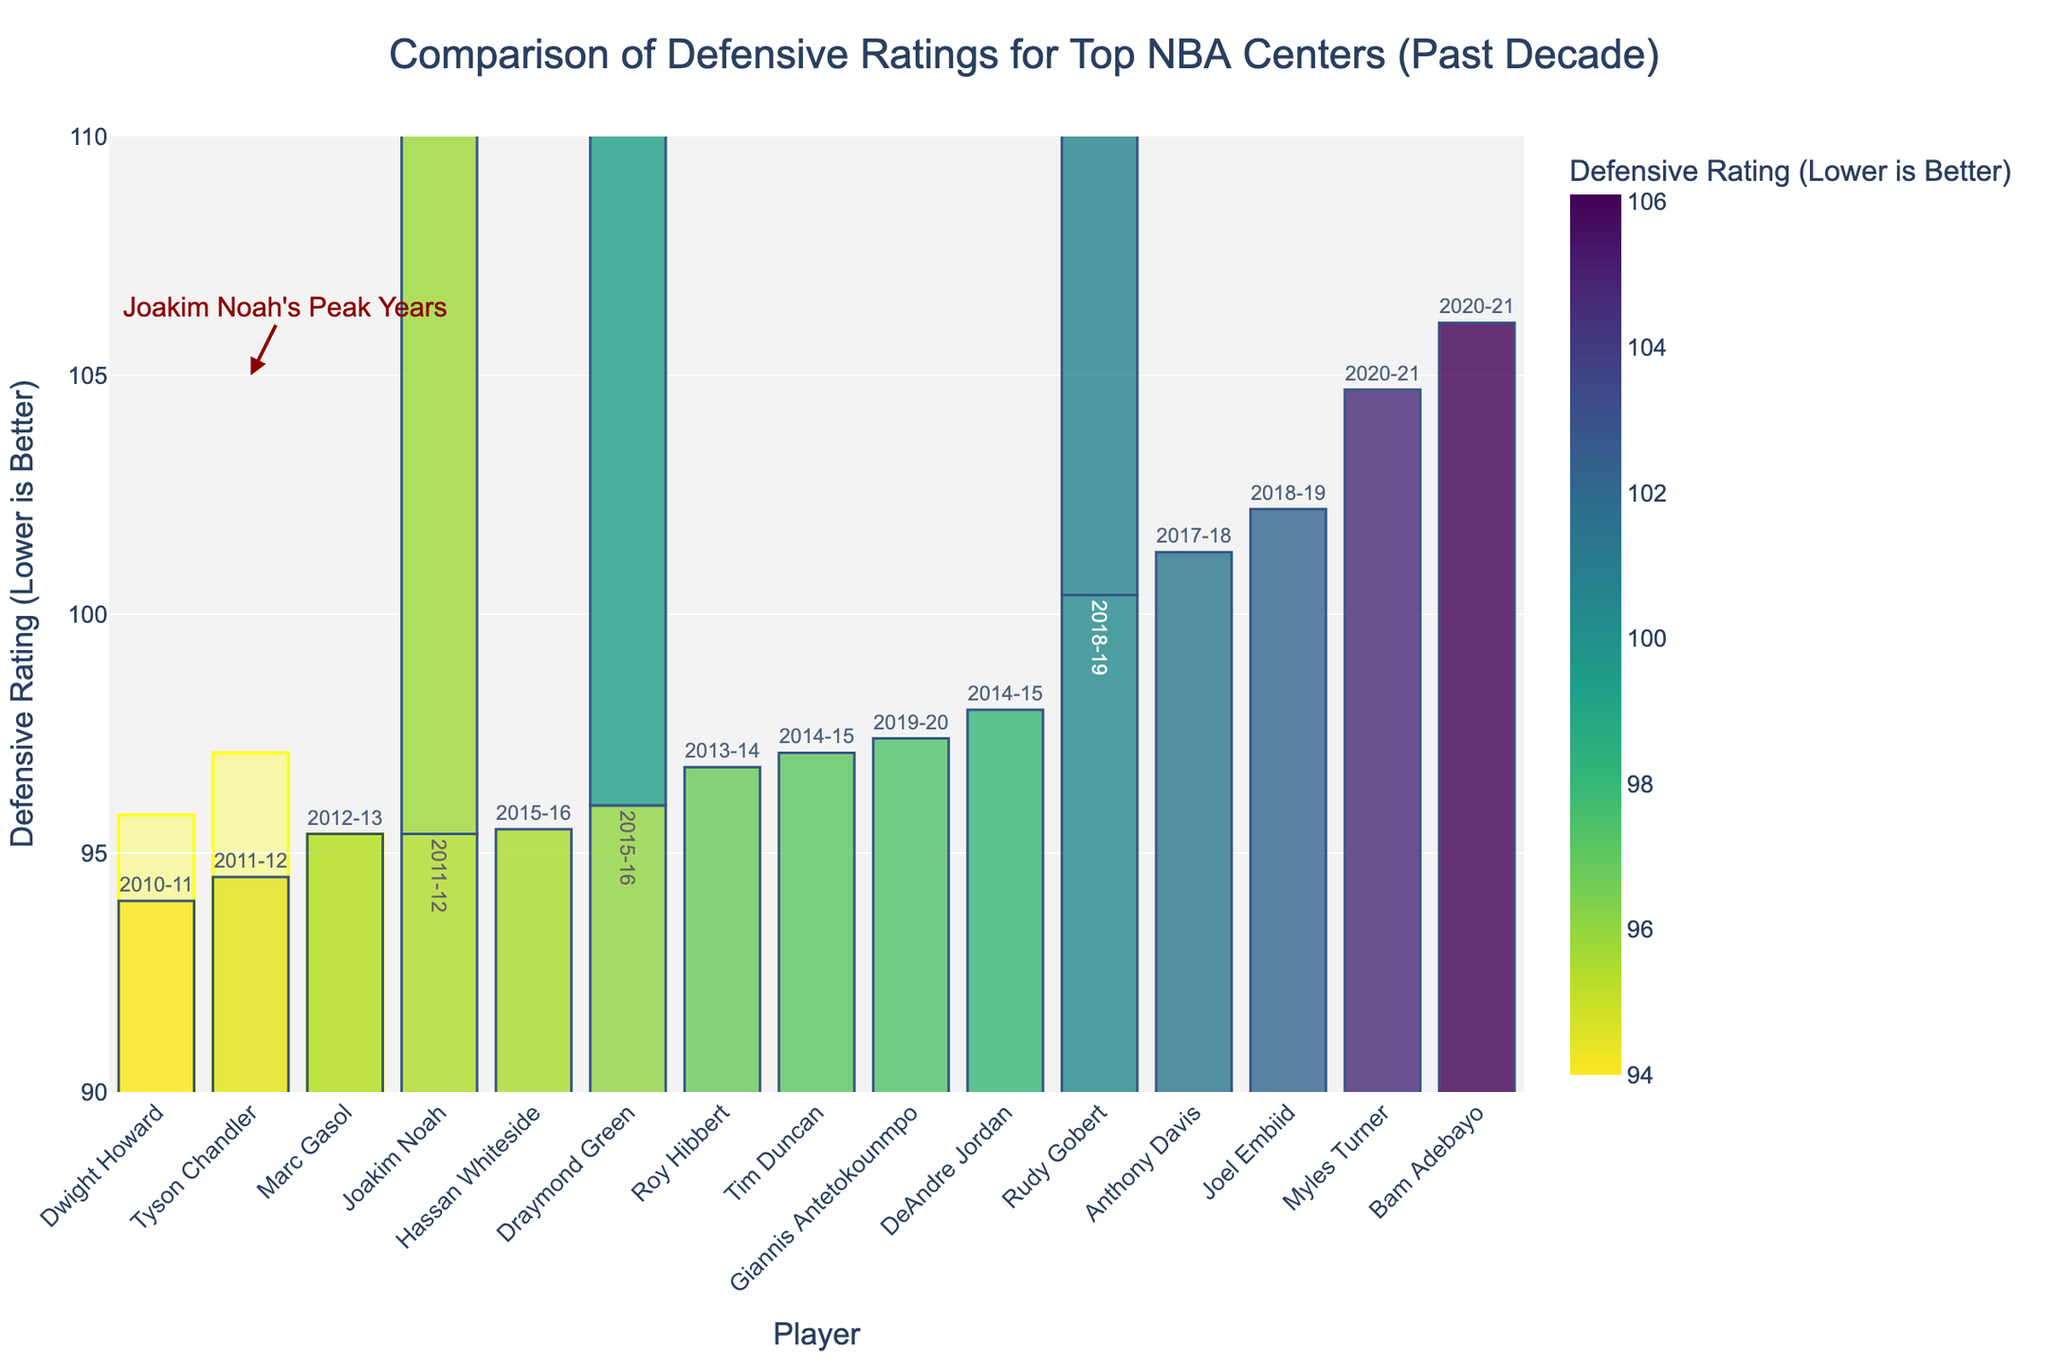Which player has the lowest defensive rating in the dataset? The player with the lowest defensive rating can be identified by finding the bar that is the shortest (indicating the lowest value) in the chart. In this case, Dwight Howard has the lowest defensive rating.
Answer: Dwight Howard What is Joakim Noah's best defensive rating, and how does it compare to Rudy Gobert's best rating? Joakim Noah's best defensive rating is 95.4, which can be seen from his 2011-12 season. Rudy Gobert's best defensive rating is 100.4 from his 2018-19 season. Comparing these values, Noah's best rating is 5.0 points better (lower) than Gobert's best rating.
Answer: Joakim Noah's best is 95.4, Rudy Gobert's best is 100.4, Noah is better by 5.0 points Which player highlighted in yellow had the lowest defensive rating during their peak years? The yellow-highlighted sections indicate Joakim Noah's peak years. Among these years, the 2011-12 season shows the lowest defensive rating at 95.4.
Answer: Joakim Noah in the 2011-12 season How does Joakim Noah's defensive rating in 2013-14 compare with Draymond Green's best defensive rating? Joakim Noah's defensive rating in 2013-14 is 95.8. Draymond Green's best defensive rating is 96.0 in the 2015-16 season. Comparing these values, Noah's rating is 0.2 points better than Green's best rating.
Answer: Noah in 2013-14 is 0.2 points better than Green's best What are the median defensive ratings for the players with ratings below 97? To determine the median, we need to find the middle value of the sorted dataset of players with ratings below 97. These players and their ratings are Dwight Howard (94.0), Tyson Chandler (94.5), Joakim Noah (95.4, 95.8, 97.1), Marc Gasol (95.4), Roy Hibbert (96.8), Draymond Green (96.0), and Joakim Noah (97.1). The median of these values is one of the middle values in the sorted list: 95.4.
Answer: 95.4 Which player has the highest defensive rating in the dataset? The player with the highest defensive rating can be identified by finding the bar that is the tallest in the chart. In this case, Bam Adebayo has the highest defensive rating at 106.1.
Answer: Bam Adebayo How does the bar height for Joakim Noah's 2012-13 season compare to Bam Adebayo's 2020-21 season? Joakim Noah's defensive rating in the 2012-13 season is 97.1, and Bam Adebayo's defensive rating in the 2020-21 season is 106.1. Visually, Noah's bar will be shorter, indicating a lower defensive rating compared to Adebayo’s taller bar.
Answer: Noah's bar is shorter than Adebayo's What is the range of defensive ratings shown in the chart? The range of the defensive ratings is the difference between the highest and lowest values. The lowest defensive rating is 94.0 (Dwight Howard) and the highest is 106.1 (Bam Adebayo). The range is calculated as 106.1 - 94.0 = 12.1.
Answer: 12.1 Which season does Joakim Noah have his highest defensive rating, and how does it compare with Marc Gasol's best year? Joakim Noah's highest defensive rating is 97.1 in the 2012-13 season. Marc Gasol's best year is 95.4 in the 2012-13 season as well. Comparing these values, Noah's rating is 1.7 points higher (worse) than Gasol's best.
Answer: Noah in 2012-13 is 1.7 points higher than Gasol's best 